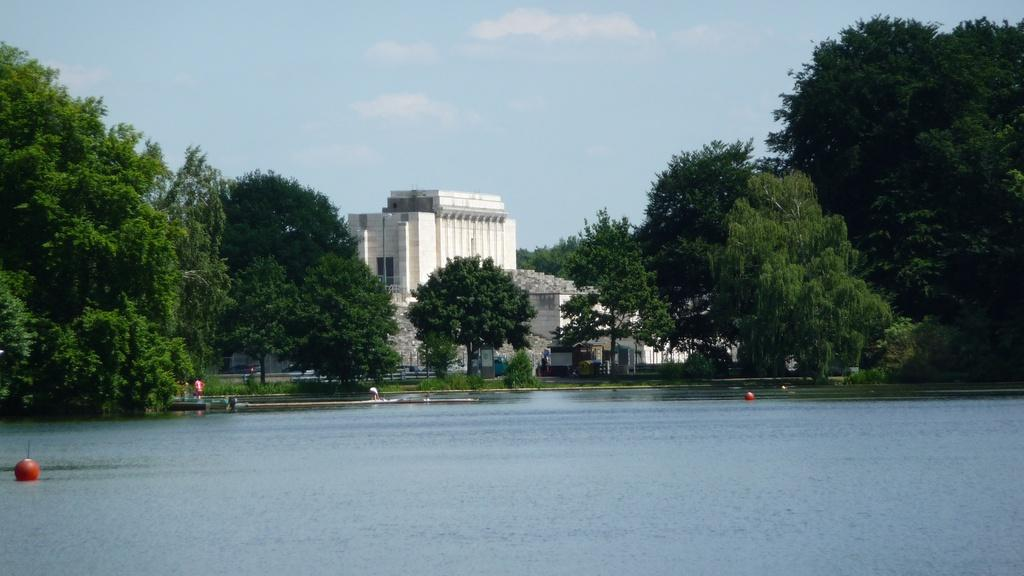What is the primary element visible in the image? There is water in the image. What type of structure can be seen in the image? There is a building in the image. What other natural elements are present in the image? There are trees in the image. What else can be seen in the image besides the water, building, and trees? There are some objects in the image. What is visible in the background of the image? The sky is visible in the background of the image. What type of mass is being held by the person in the image? There is no person present in the image, so it is not possible to determine what mass they might be holding. 